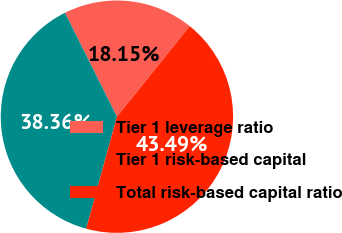Convert chart. <chart><loc_0><loc_0><loc_500><loc_500><pie_chart><fcel>Tier 1 leverage ratio<fcel>Tier 1 risk-based capital<fcel>Total risk-based capital ratio<nl><fcel>18.15%<fcel>38.36%<fcel>43.49%<nl></chart> 